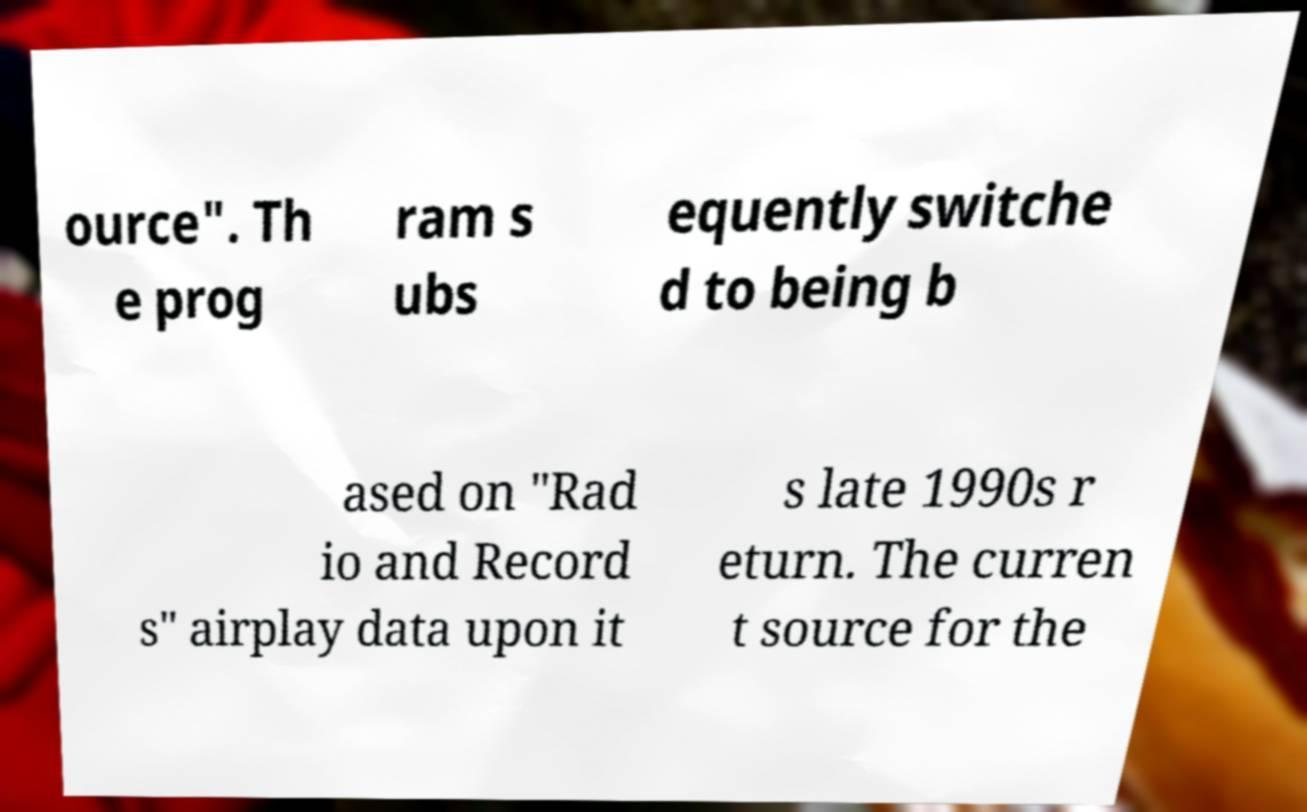Could you extract and type out the text from this image? ource". Th e prog ram s ubs equently switche d to being b ased on "Rad io and Record s" airplay data upon it s late 1990s r eturn. The curren t source for the 